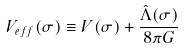<formula> <loc_0><loc_0><loc_500><loc_500>V _ { e f f } ( \sigma ) \equiv V ( \sigma ) + \frac { \hat { \Lambda } ( \sigma ) } { 8 \pi G }</formula> 